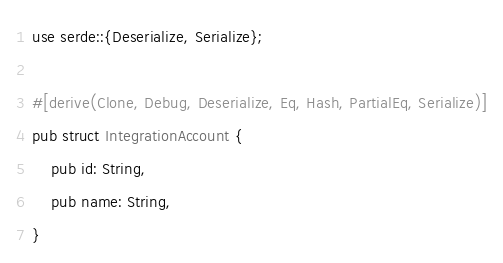Convert code to text. <code><loc_0><loc_0><loc_500><loc_500><_Rust_>use serde::{Deserialize, Serialize};

#[derive(Clone, Debug, Deserialize, Eq, Hash, PartialEq, Serialize)]
pub struct IntegrationAccount {
    pub id: String,
    pub name: String,
}
</code> 